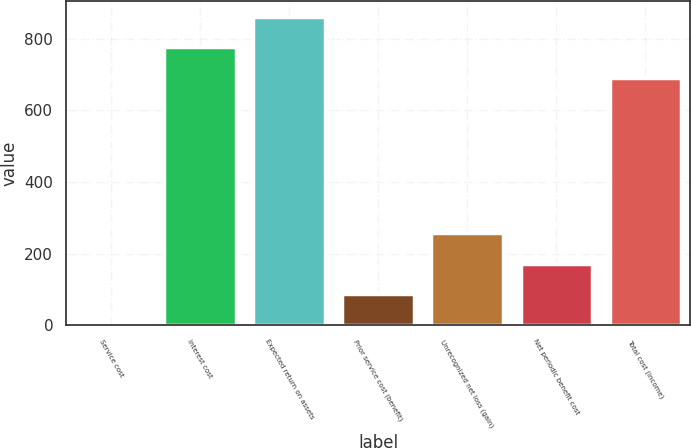Convert chart. <chart><loc_0><loc_0><loc_500><loc_500><bar_chart><fcel>Service cost<fcel>Interest cost<fcel>Expected return on assets<fcel>Prior service cost (benefit)<fcel>Unrecognized net loss (gain)<fcel>Net periodic benefit cost<fcel>Total cost (income)<nl><fcel>2<fcel>775.9<fcel>860.8<fcel>86.9<fcel>256.7<fcel>171.8<fcel>691<nl></chart> 